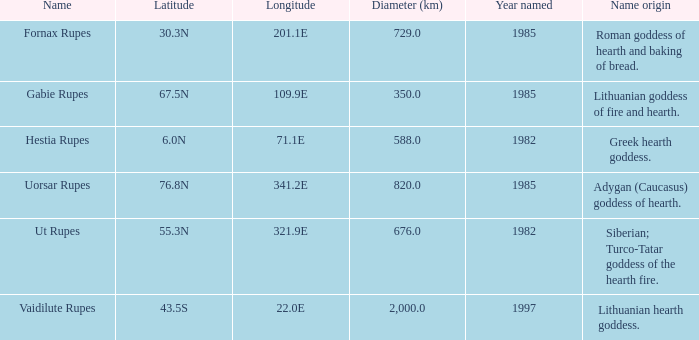9e, what is the features' latitude discovered? 55.3N. 